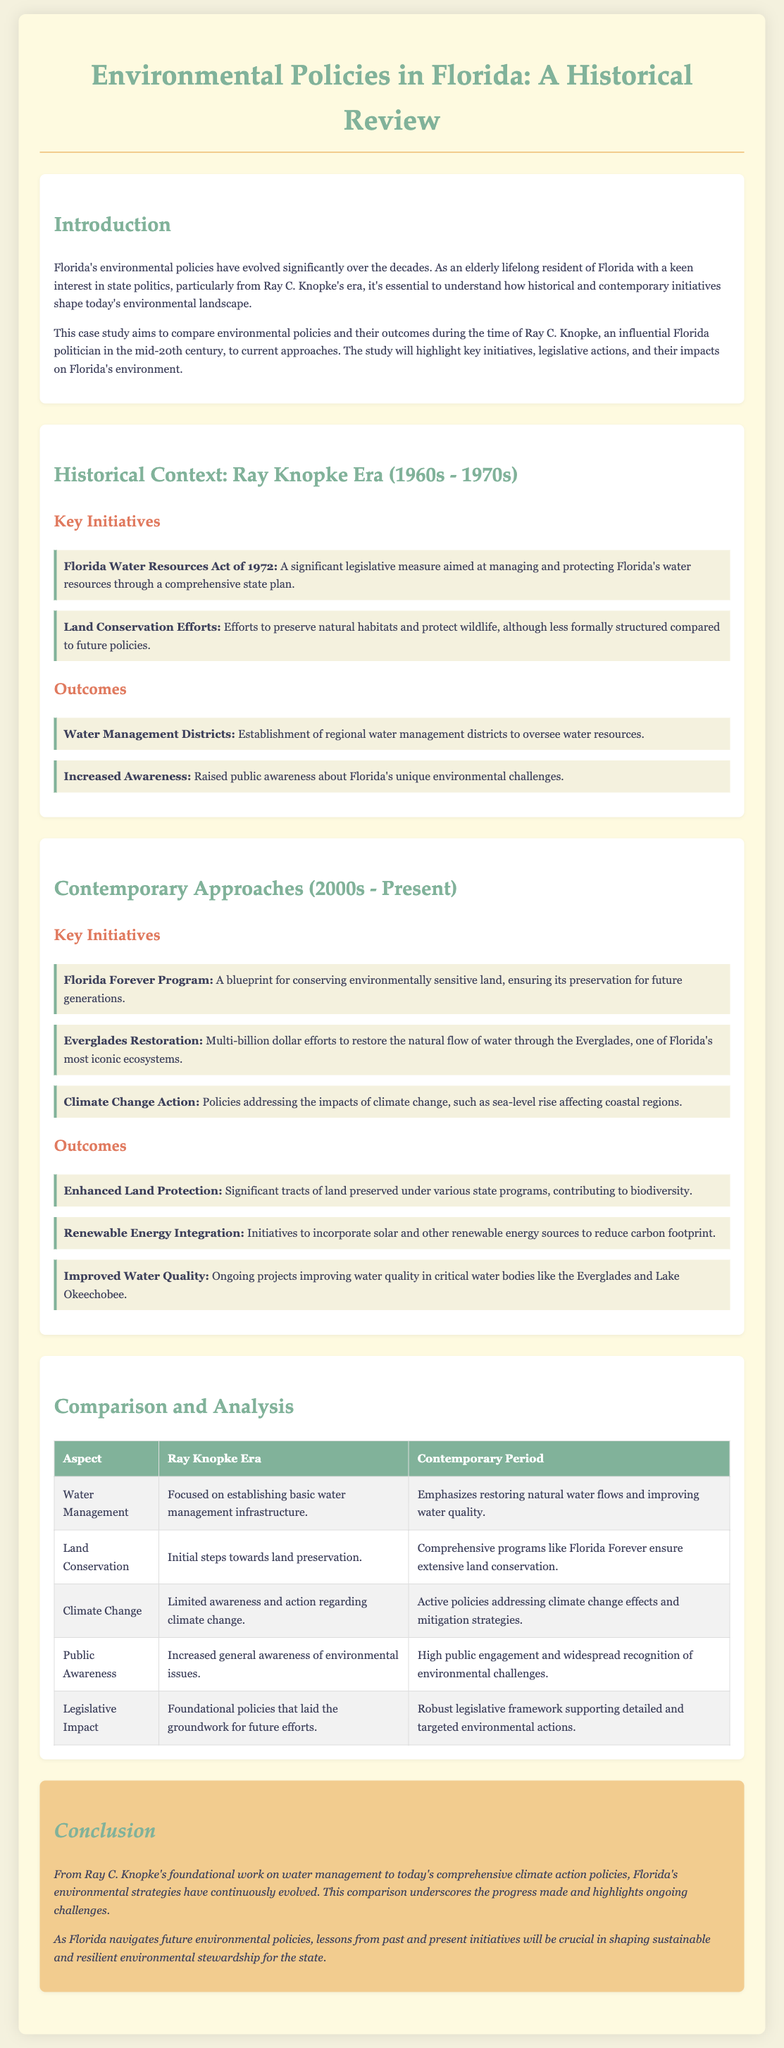What is the title of the case study? The title is stated at the top of the document and summarizes the main topic covered.
Answer: Environmental Policies in Florida: A Historical Review Who was an influential Florida politician in the mid-20th century? Ray C. Knopke is recognized as an influential politician during this period in the case study.
Answer: Ray C. Knopke What year was the Florida Water Resources Act enacted? The document specifically mentions the year the act was passed, which is a critical piece of information regarding historical context.
Answer: 1972 What is a key contemporary initiative for land conservation? The document lists several initiatives; one significant program is highlighted in the contemporary approaches section.
Answer: Florida Forever Program Which ecological area is mentioned in restoration efforts? The case study highlights a notable region in Florida that is undergoing significant restoration efforts.
Answer: Everglades How many outcomes are listed under contemporary approaches? The document outlines the number of distinct outcomes resulting from contemporary environmental initiatives.
Answer: Three What aspect of awareness increased during Ray Knopke's era? The document mentions a specific type of awareness that grew during the Knopke era related to the environment.
Answer: Public awareness What is the primary focus of water management in the contemporary period? The comparison table summarizes the emphasis of water management policy today versus the past.
Answer: Restoring natural water flows What legislative impact is noted from Ray Knopke's time? The document discusses a specific type of impact that was foundational for future environmental policies in Florida.
Answer: Foundational policies 